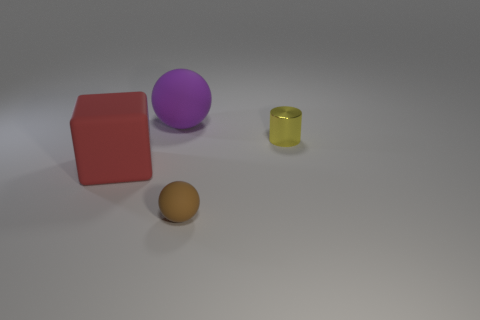Add 1 red rubber things. How many objects exist? 5 Subtract all cylinders. How many objects are left? 3 Subtract all tiny brown rubber things. Subtract all purple spheres. How many objects are left? 2 Add 4 big red matte blocks. How many big red matte blocks are left? 5 Add 4 big rubber spheres. How many big rubber spheres exist? 5 Subtract 0 yellow cubes. How many objects are left? 4 